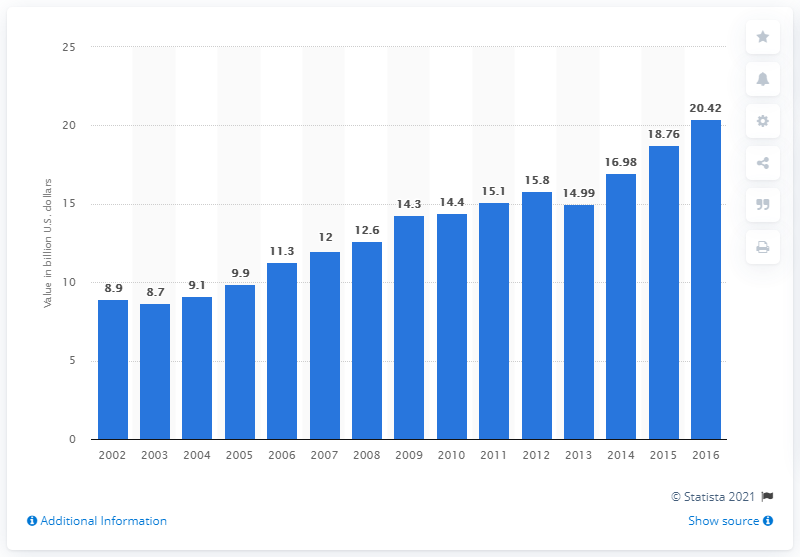Identify some key points in this picture. In 2016, the value of wine, brandy, and brandy spirits in the U.S. was approximately 20.42. 